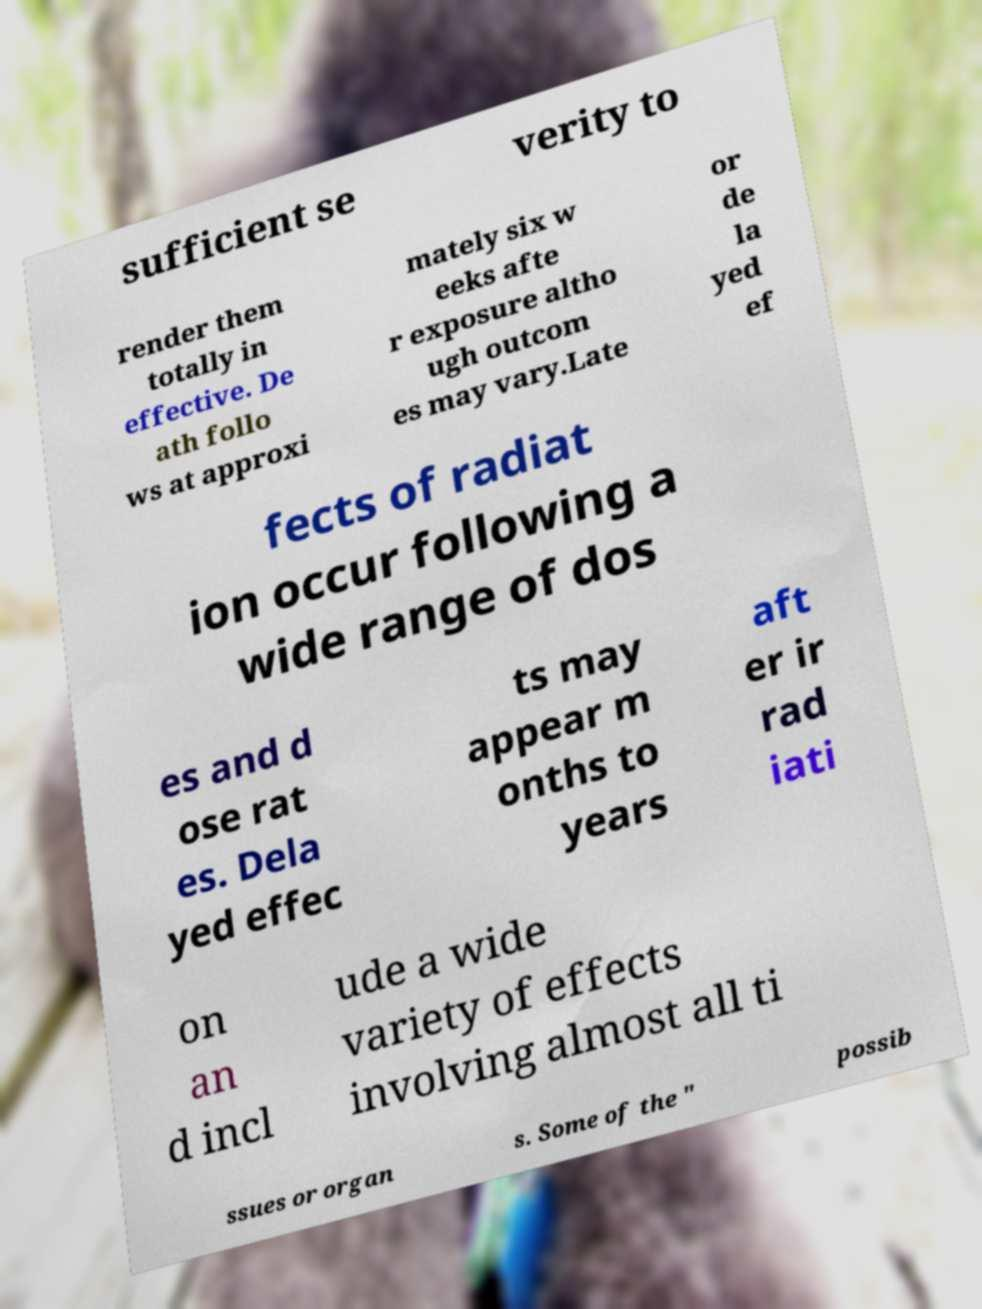Could you assist in decoding the text presented in this image and type it out clearly? sufficient se verity to render them totally in effective. De ath follo ws at approxi mately six w eeks afte r exposure altho ugh outcom es may vary.Late or de la yed ef fects of radiat ion occur following a wide range of dos es and d ose rat es. Dela yed effec ts may appear m onths to years aft er ir rad iati on an d incl ude a wide variety of effects involving almost all ti ssues or organ s. Some of the " possib 